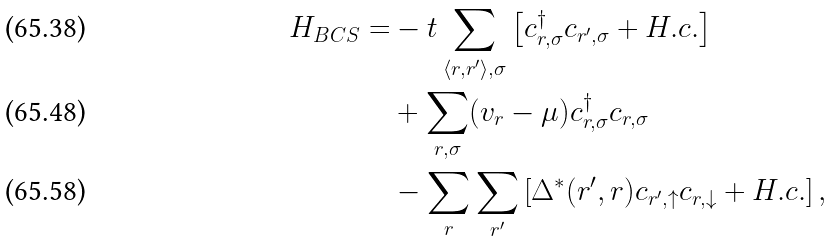<formula> <loc_0><loc_0><loc_500><loc_500>H _ { B C S } = & - t \sum _ { \langle r , r ^ { \prime } \rangle , \sigma } \left [ c _ { r , \sigma } ^ { \dagger } c _ { r ^ { \prime } , \sigma } + H . c . \right ] \\ & + \sum _ { r , \sigma } ( v _ { r } - \mu ) c _ { r , \sigma } ^ { \dagger } c _ { r , \sigma } \\ & - \sum _ { r } \sum _ { r ^ { \prime } } \left [ { \Delta } ^ { \ast } ( r ^ { \prime } , r ) c _ { r ^ { \prime } , \uparrow } c _ { r , \downarrow } + H . c . \right ] ,</formula> 